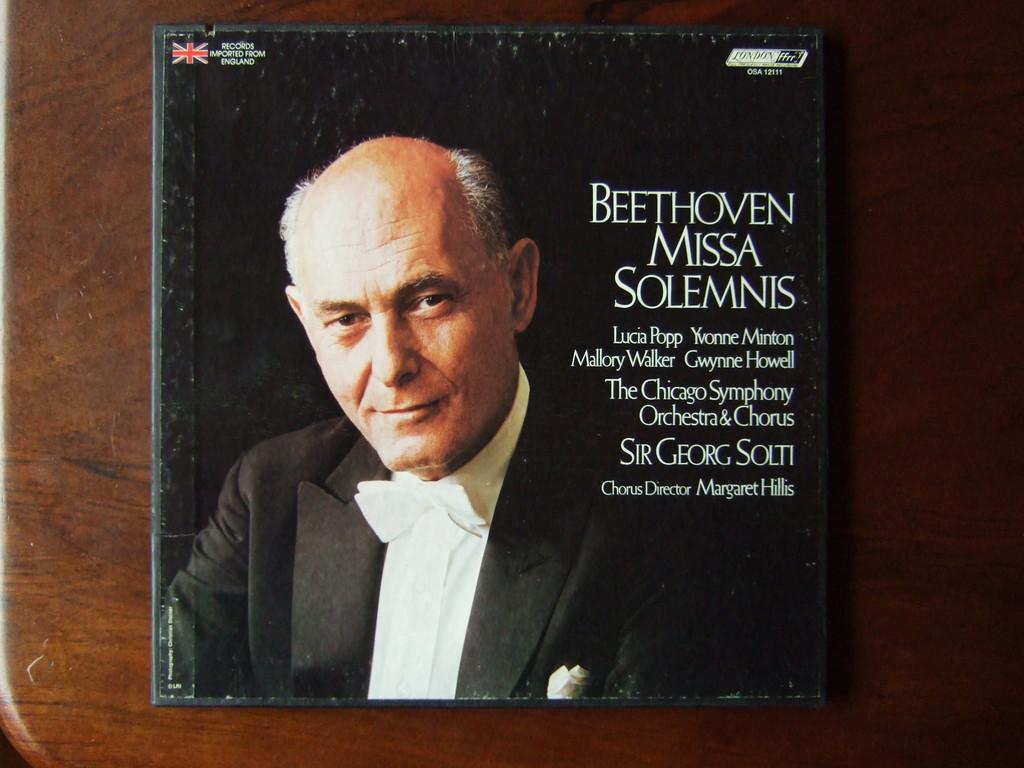What flag is on the top left?
Your response must be concise. British. 